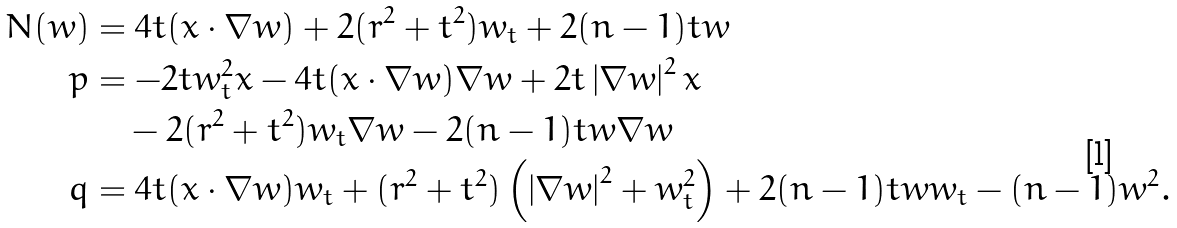<formula> <loc_0><loc_0><loc_500><loc_500>N ( w ) & = 4 t ( x \cdot \nabla w ) + 2 ( r ^ { 2 } + t ^ { 2 } ) w _ { t } + 2 ( n - 1 ) t w \\ p & = - 2 t w _ { t } ^ { 2 } x - 4 t ( x \cdot \nabla w ) \nabla w + 2 t \left | \nabla w \right | ^ { 2 } x \\ & \quad - 2 ( r ^ { 2 } + t ^ { 2 } ) w _ { t } \nabla w - 2 ( n - 1 ) t w \nabla w \\ q & = 4 t ( x \cdot \nabla w ) w _ { t } + ( r ^ { 2 } + t ^ { 2 } ) \left ( \left | \nabla w \right | ^ { 2 } + w _ { t } ^ { 2 } \right ) + 2 ( n - 1 ) t w w _ { t } - ( n - 1 ) w ^ { 2 } .</formula> 